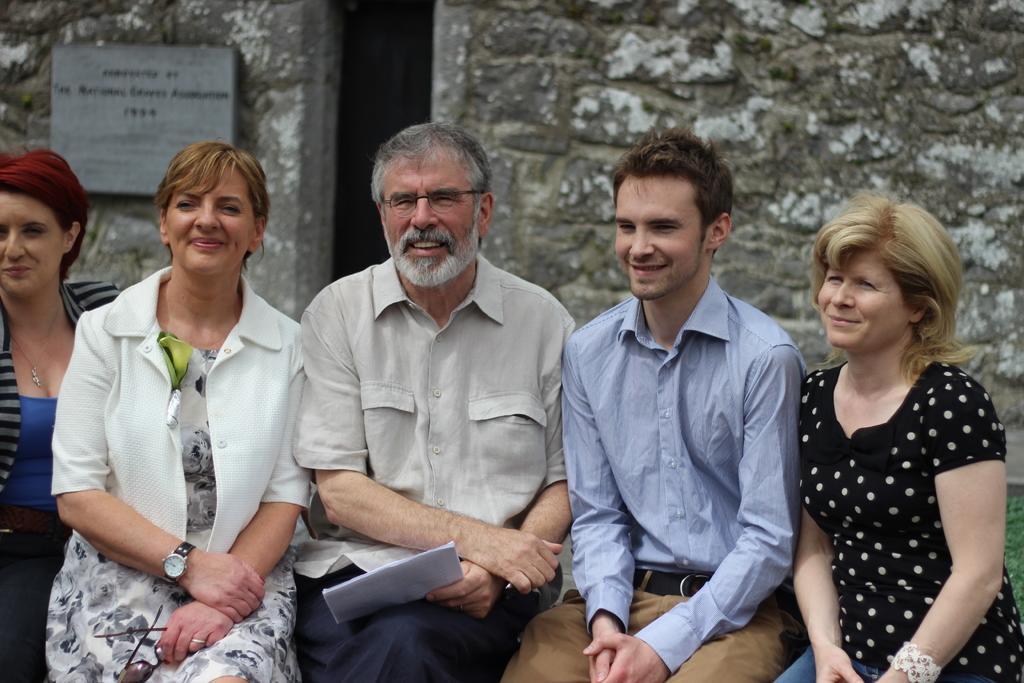How would you summarize this image in a sentence or two? In this picture there are group of people sitting and smiling and the person with off white shirt is sitting and holding the paper. At the back there is a board on the wall and there is a text on the board. On the right side of the image there are plants. 